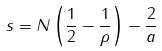<formula> <loc_0><loc_0><loc_500><loc_500>s = N \left ( \frac { 1 } { 2 } - \frac { 1 } { \rho } \right ) - \frac { 2 } { a }</formula> 